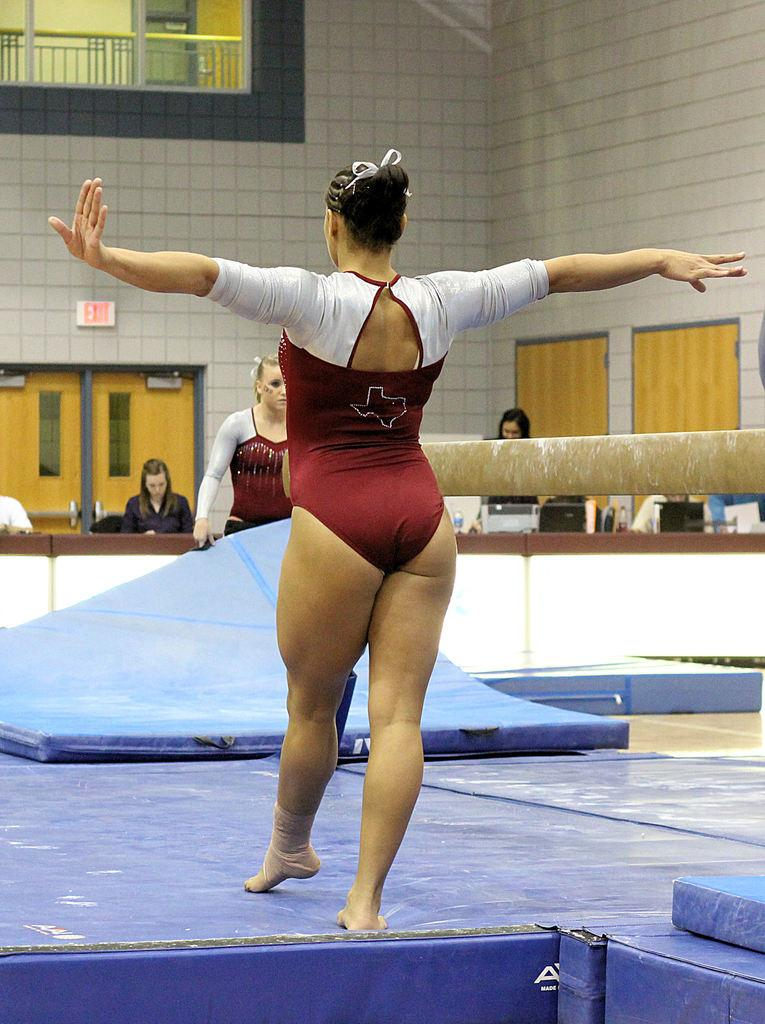What is the woman standing on in the image? The woman is standing on a blue object. What can be seen in the background of the image? There are people, objects, a wall, a door, a sign board, a glass object, and a railing in the background of the image. Can you describe the setting of the image? The image shows a woman standing on a blue object with various elements in the background, including a wall, a door, and a railing. How many children are holding trays in the image? There are no children or trays present in the image. What is the base of the glass object in the image? The provided facts do not mention the base of the glass object, so we cannot answer this question definitively. 